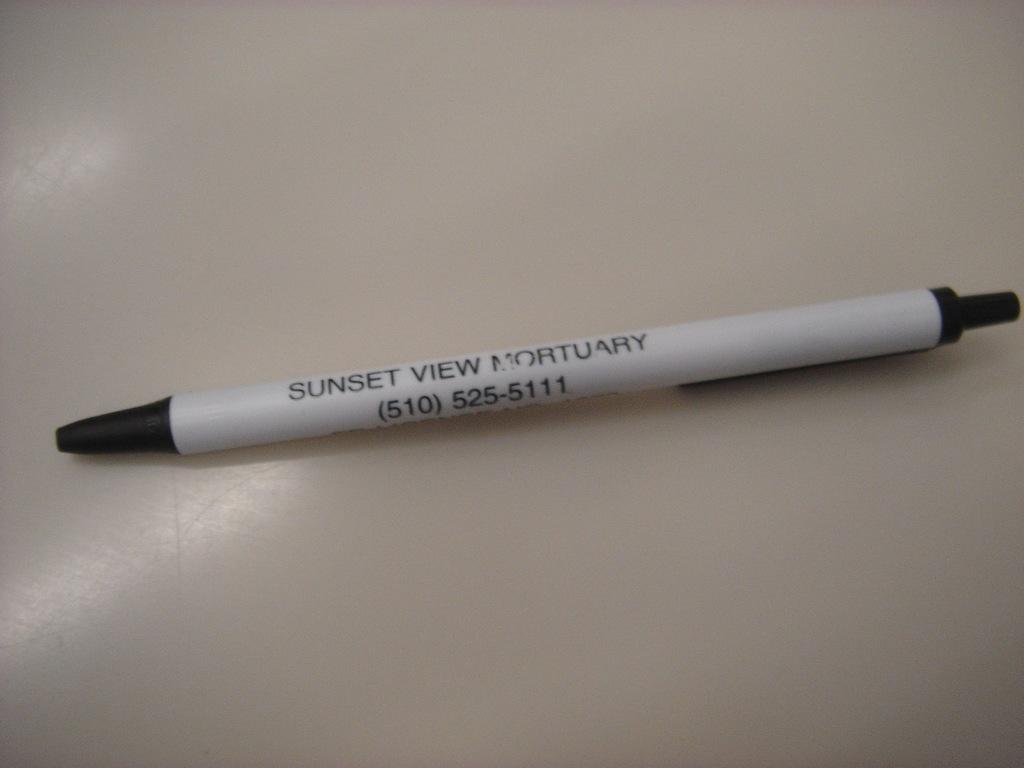What is the main object in the center of the image? There is a pen in the center of the image. What can be found on the pen? The pen has text and numbers on it. What is the color of the surface at the bottom of the image? The surface at the bottom of the image is white. Where are the scissors located in the image? There are no scissors present in the image. What type of stick can be seen leaning against the pen in the image? There is no stick present in the image; only the pen is visible. 